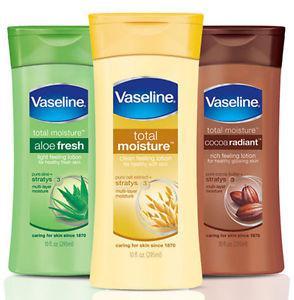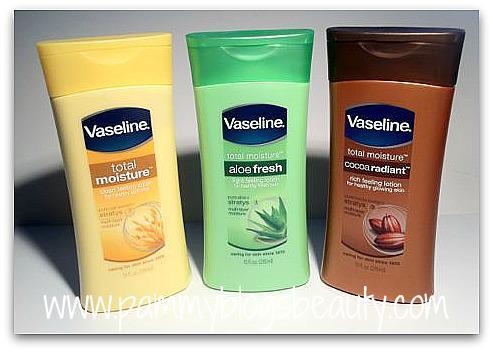The first image is the image on the left, the second image is the image on the right. Given the left and right images, does the statement "Lotions are in groups of three with flip-top lids." hold true? Answer yes or no. Yes. 